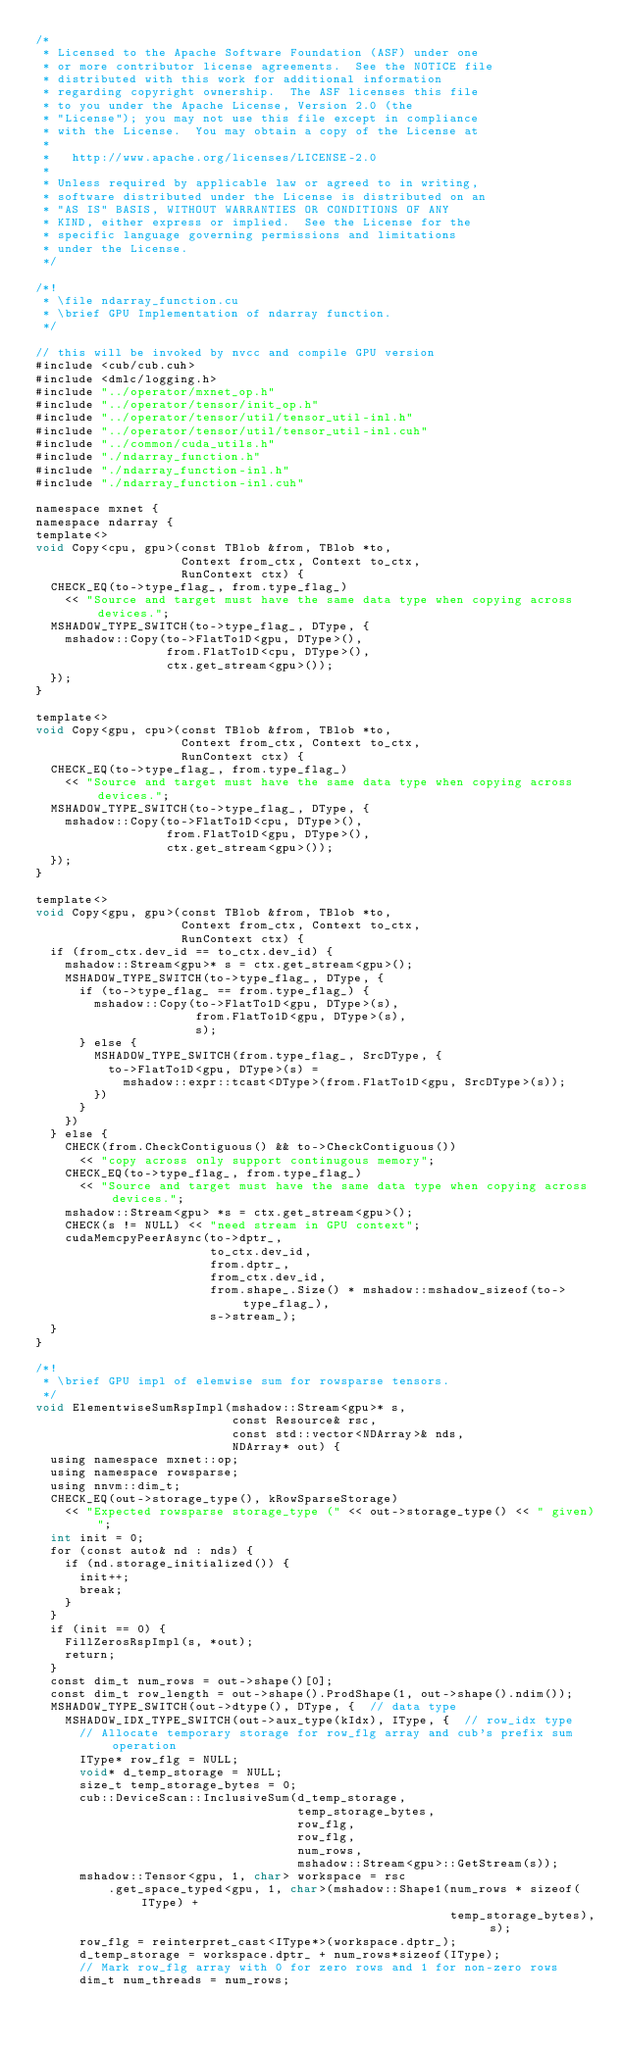<code> <loc_0><loc_0><loc_500><loc_500><_Cuda_>/*
 * Licensed to the Apache Software Foundation (ASF) under one
 * or more contributor license agreements.  See the NOTICE file
 * distributed with this work for additional information
 * regarding copyright ownership.  The ASF licenses this file
 * to you under the Apache License, Version 2.0 (the
 * "License"); you may not use this file except in compliance
 * with the License.  You may obtain a copy of the License at
 *
 *   http://www.apache.org/licenses/LICENSE-2.0
 *
 * Unless required by applicable law or agreed to in writing,
 * software distributed under the License is distributed on an
 * "AS IS" BASIS, WITHOUT WARRANTIES OR CONDITIONS OF ANY
 * KIND, either express or implied.  See the License for the
 * specific language governing permissions and limitations
 * under the License.
 */

/*!
 * \file ndarray_function.cu
 * \brief GPU Implementation of ndarray function.
 */

// this will be invoked by nvcc and compile GPU version
#include <cub/cub.cuh>
#include <dmlc/logging.h>
#include "../operator/mxnet_op.h"
#include "../operator/tensor/init_op.h"
#include "../operator/tensor/util/tensor_util-inl.h"
#include "../operator/tensor/util/tensor_util-inl.cuh"
#include "../common/cuda_utils.h"
#include "./ndarray_function.h"
#include "./ndarray_function-inl.h"
#include "./ndarray_function-inl.cuh"

namespace mxnet {
namespace ndarray {
template<>
void Copy<cpu, gpu>(const TBlob &from, TBlob *to,
                    Context from_ctx, Context to_ctx,
                    RunContext ctx) {
  CHECK_EQ(to->type_flag_, from.type_flag_)
    << "Source and target must have the same data type when copying across devices.";
  MSHADOW_TYPE_SWITCH(to->type_flag_, DType, {
    mshadow::Copy(to->FlatTo1D<gpu, DType>(),
                  from.FlatTo1D<cpu, DType>(),
                  ctx.get_stream<gpu>());
  });
}

template<>
void Copy<gpu, cpu>(const TBlob &from, TBlob *to,
                    Context from_ctx, Context to_ctx,
                    RunContext ctx) {
  CHECK_EQ(to->type_flag_, from.type_flag_)
    << "Source and target must have the same data type when copying across devices.";
  MSHADOW_TYPE_SWITCH(to->type_flag_, DType, {
    mshadow::Copy(to->FlatTo1D<cpu, DType>(),
                  from.FlatTo1D<gpu, DType>(),
                  ctx.get_stream<gpu>());
  });
}

template<>
void Copy<gpu, gpu>(const TBlob &from, TBlob *to,
                    Context from_ctx, Context to_ctx,
                    RunContext ctx) {
  if (from_ctx.dev_id == to_ctx.dev_id) {
    mshadow::Stream<gpu>* s = ctx.get_stream<gpu>();
    MSHADOW_TYPE_SWITCH(to->type_flag_, DType, {
      if (to->type_flag_ == from.type_flag_) {
        mshadow::Copy(to->FlatTo1D<gpu, DType>(s),
                      from.FlatTo1D<gpu, DType>(s),
                      s);
      } else {
        MSHADOW_TYPE_SWITCH(from.type_flag_, SrcDType, {
          to->FlatTo1D<gpu, DType>(s) =
            mshadow::expr::tcast<DType>(from.FlatTo1D<gpu, SrcDType>(s));
        })
      }
    })
  } else {
    CHECK(from.CheckContiguous() && to->CheckContiguous())
      << "copy across only support continugous memory";
    CHECK_EQ(to->type_flag_, from.type_flag_)
      << "Source and target must have the same data type when copying across devices.";
    mshadow::Stream<gpu> *s = ctx.get_stream<gpu>();
    CHECK(s != NULL) << "need stream in GPU context";
    cudaMemcpyPeerAsync(to->dptr_,
                        to_ctx.dev_id,
                        from.dptr_,
                        from_ctx.dev_id,
                        from.shape_.Size() * mshadow::mshadow_sizeof(to->type_flag_),
                        s->stream_);
  }
}

/*!
 * \brief GPU impl of elemwise sum for rowsparse tensors.
 */
void ElementwiseSumRspImpl(mshadow::Stream<gpu>* s,
                           const Resource& rsc,
                           const std::vector<NDArray>& nds,
                           NDArray* out) {
  using namespace mxnet::op;
  using namespace rowsparse;
  using nnvm::dim_t;
  CHECK_EQ(out->storage_type(), kRowSparseStorage)
    << "Expected rowsparse storage_type (" << out->storage_type() << " given)";
  int init = 0;
  for (const auto& nd : nds) {
    if (nd.storage_initialized()) {
      init++;
      break;
    }
  }
  if (init == 0) {
    FillZerosRspImpl(s, *out);
    return;
  }
  const dim_t num_rows = out->shape()[0];
  const dim_t row_length = out->shape().ProdShape(1, out->shape().ndim());
  MSHADOW_TYPE_SWITCH(out->dtype(), DType, {  // data type
    MSHADOW_IDX_TYPE_SWITCH(out->aux_type(kIdx), IType, {  // row_idx type
      // Allocate temporary storage for row_flg array and cub's prefix sum operation
      IType* row_flg = NULL;
      void* d_temp_storage = NULL;
      size_t temp_storage_bytes = 0;
      cub::DeviceScan::InclusiveSum(d_temp_storage,
                                    temp_storage_bytes,
                                    row_flg,
                                    row_flg,
                                    num_rows,
                                    mshadow::Stream<gpu>::GetStream(s));
      mshadow::Tensor<gpu, 1, char> workspace = rsc
          .get_space_typed<gpu, 1, char>(mshadow::Shape1(num_rows * sizeof(IType) +
                                                         temp_storage_bytes), s);
      row_flg = reinterpret_cast<IType*>(workspace.dptr_);
      d_temp_storage = workspace.dptr_ + num_rows*sizeof(IType);
      // Mark row_flg array with 0 for zero rows and 1 for non-zero rows
      dim_t num_threads = num_rows;</code> 